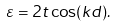Convert formula to latex. <formula><loc_0><loc_0><loc_500><loc_500>\varepsilon = 2 t \cos ( k d ) .</formula> 